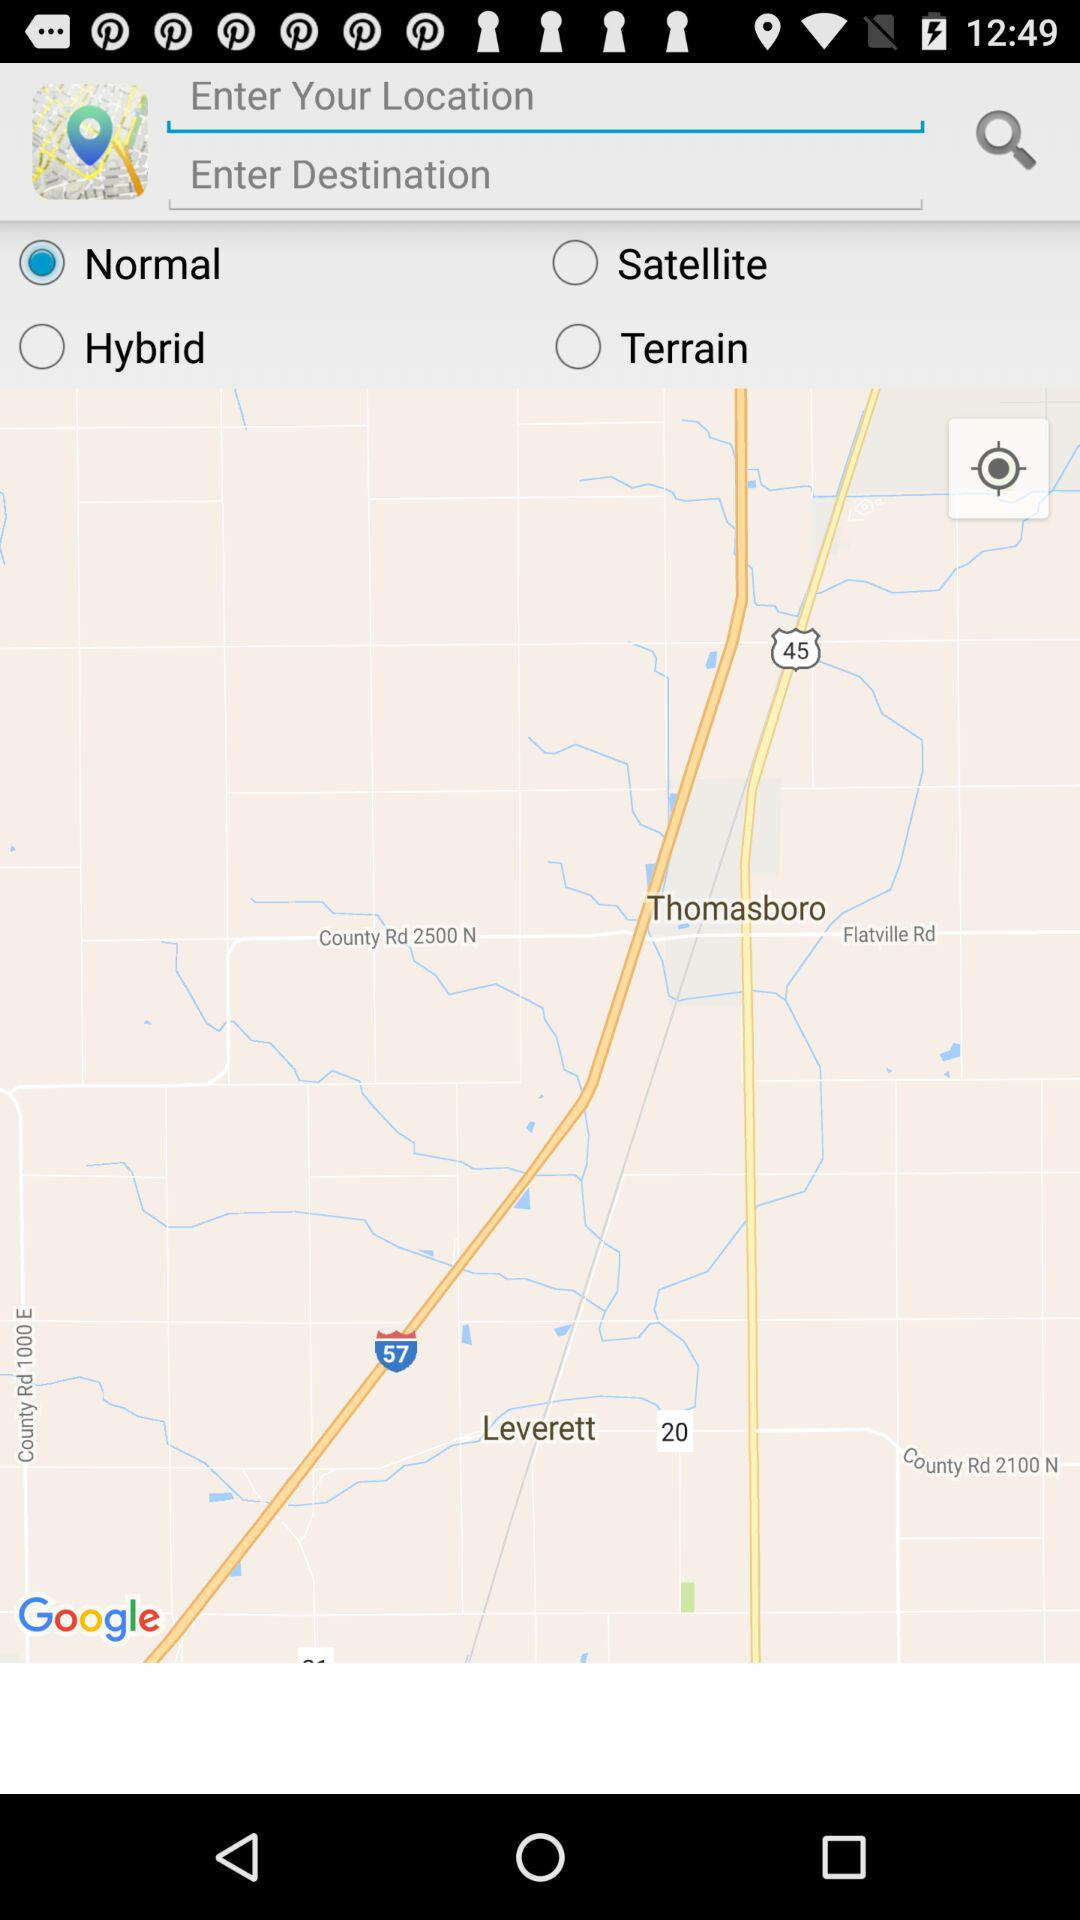What are the available options? The available options are "Normal", "Satellite", "Hybrid", "Terrain" and "Current location". 